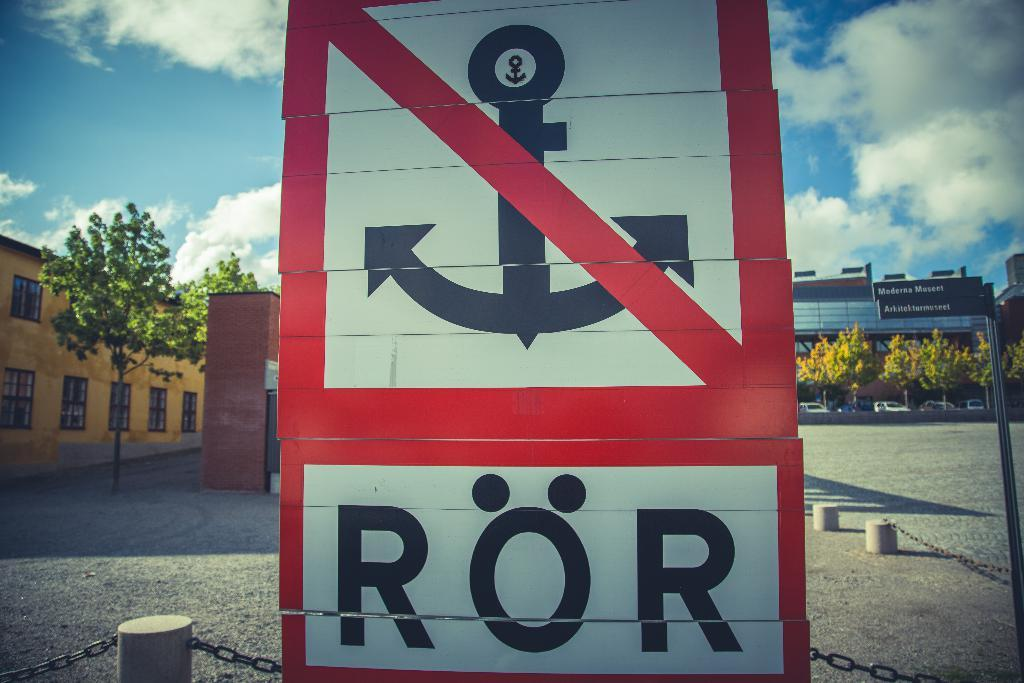<image>
Write a terse but informative summary of the picture. A white signpost with red border and the letters ROR at the bottom. 